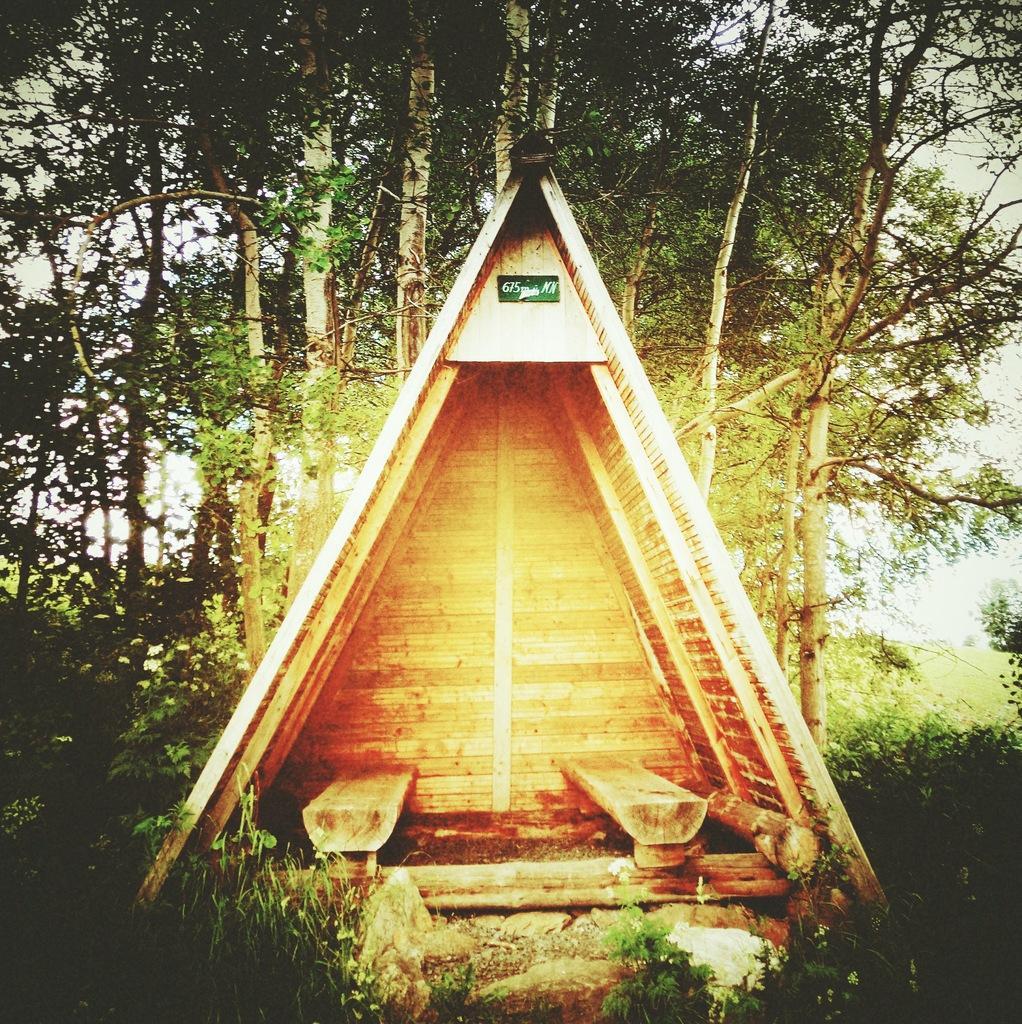How would you summarize this image in a sentence or two? In this picture I can see a wooden cabin, there are plants, and in the background there are trees. 